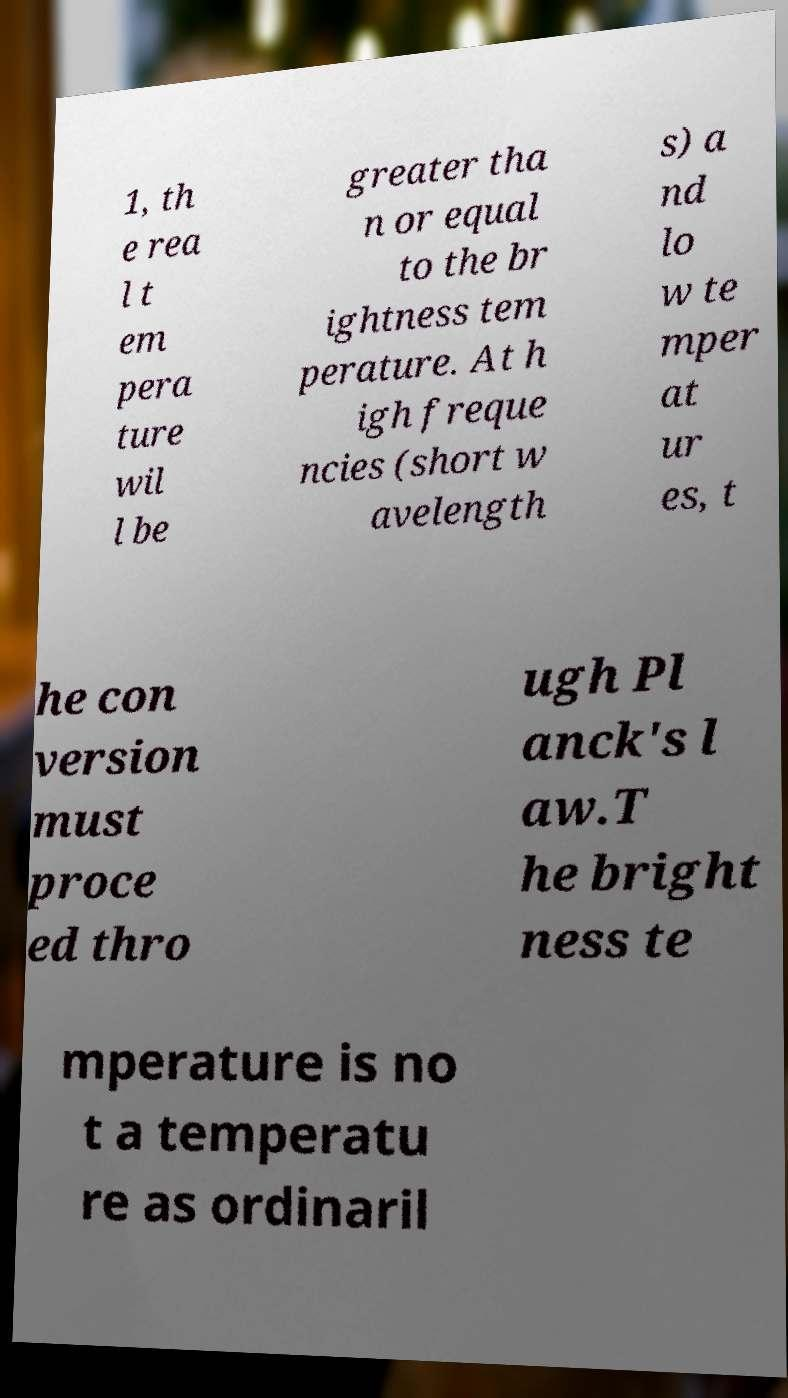Can you accurately transcribe the text from the provided image for me? 1, th e rea l t em pera ture wil l be greater tha n or equal to the br ightness tem perature. At h igh freque ncies (short w avelength s) a nd lo w te mper at ur es, t he con version must proce ed thro ugh Pl anck's l aw.T he bright ness te mperature is no t a temperatu re as ordinaril 